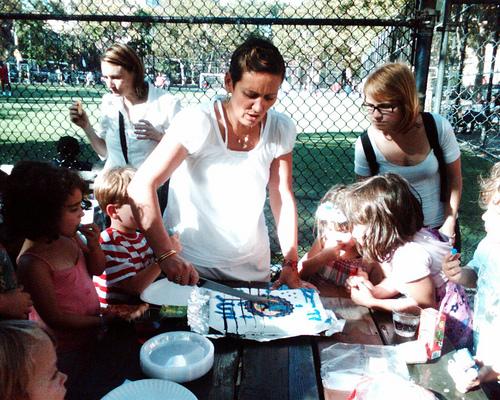What is the woman cutting?
Keep it brief. Cake. Are the kids ready for some cake?
Quick response, please. Yes. What are they celebrating?
Be succinct. Birthday. Is it hot or cold outside in this picture?
Write a very short answer. Hot. 